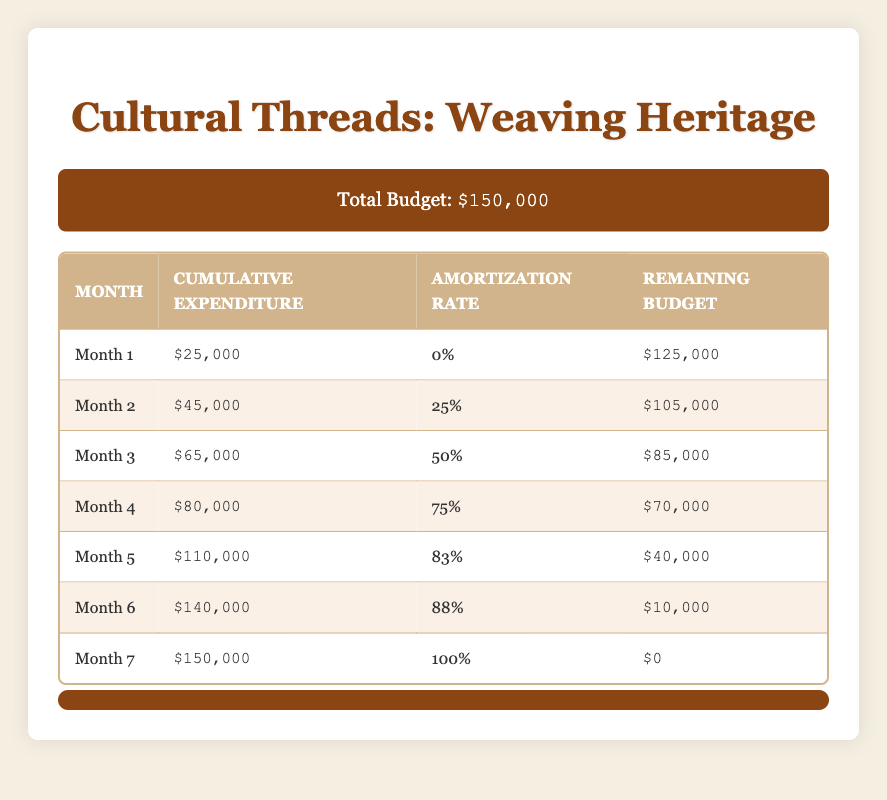What is the total budget for the film project? The total budget is explicitly stated in the budget info at the top of the table as $150,000.
Answer: $150,000 What is the cumulative expenditure at Month 4? The cumulative expenditure for Month 4 can be found directly in the table under the corresponding row, which shows $80,000.
Answer: $80,000 How much was the allocated budget for the PostProduction phase? The budget breakdown specifies that the amount allocated for PostProduction is $30,000.
Answer: $30,000 What is the amortization rate in Month 5? The amortization rate for Month 5 is located in the table, shown as 83% in the respective row.
Answer: 83% What is the remaining budget after Month 3? To find the remaining budget after Month 3, we check the table which indicates a remaining budget of $85,000 in that row.
Answer: $85,000 Did the cumulative expenditure exceed the total budget at any point in the schedule? Looking through the cumulative expenditure row, the maximum value is $150,000 in Month 7, which is equal to the total budget, but no month exceeds it. So the answer is no.
Answer: No If we add the cumulative expenditures of Month 2 and Month 3, what is the total? The cumulative expenditure for Month 2 is $45,000 and for Month 3 is $65,000. Adding them together results in $45,000 + $65,000 = $110,000.
Answer: $110,000 By what percentage did the remaining budget decrease from Month 1 to Month 2? The remaining budget in Month 1 is $125,000 and in Month 2 is $105,000. The decrease is $125,000 - $105,000 = $20,000. To find the percentage decrease: ($20,000 / $125,000) * 100 = 16%.
Answer: 16% What cumulative expenditure correlates with a remaining budget of $10,000? By examining the table, it shows that a remaining budget of $10,000 corresponds to a cumulative expenditure of $140,000 in Month 6.
Answer: $140,000 